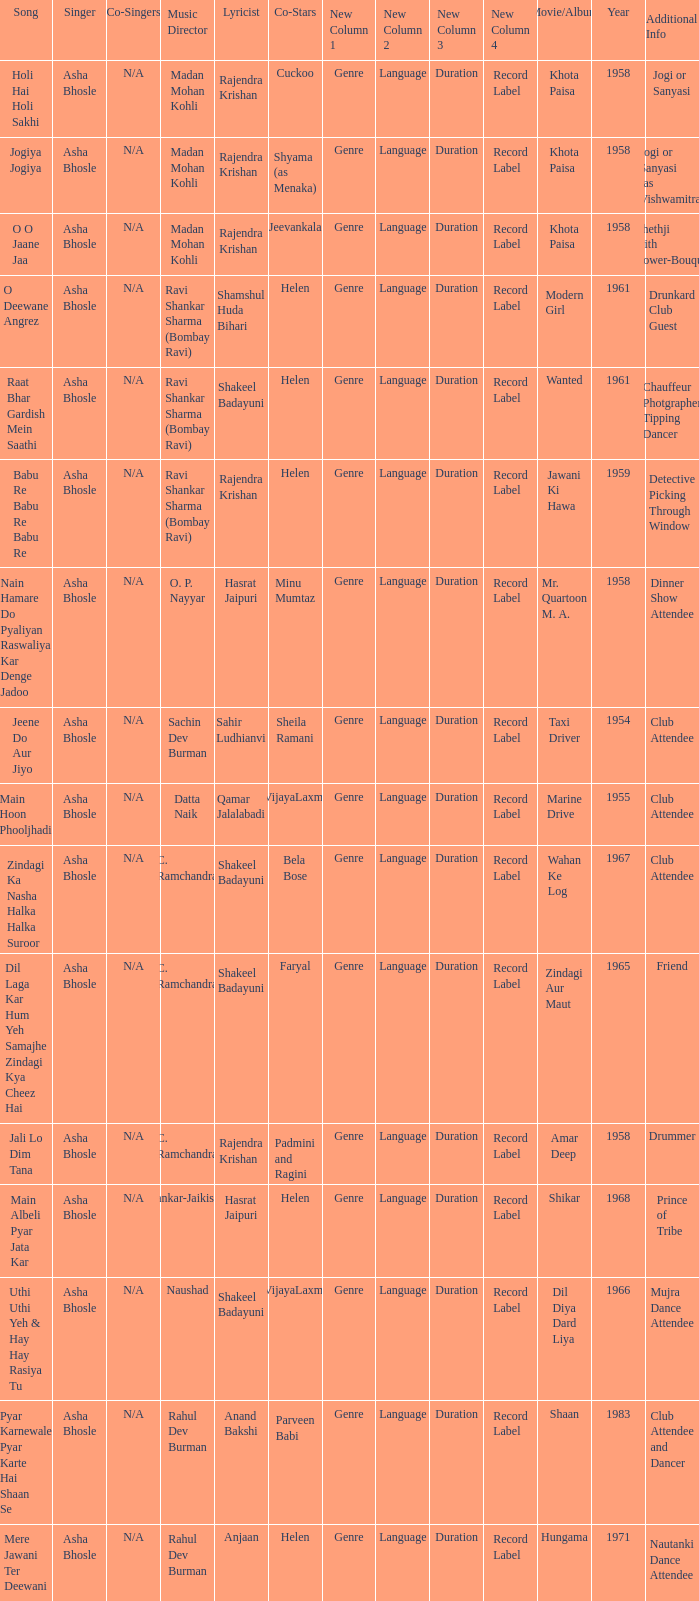Who sang for the movie Amar Deep? Asha Bhosle. 